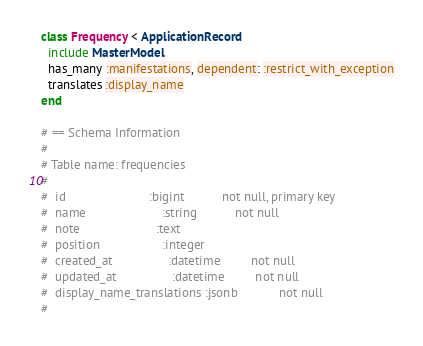Convert code to text. <code><loc_0><loc_0><loc_500><loc_500><_Ruby_>class Frequency < ApplicationRecord
  include MasterModel
  has_many :manifestations, dependent: :restrict_with_exception
  translates :display_name
end

# == Schema Information
#
# Table name: frequencies
#
#  id                        :bigint           not null, primary key
#  name                      :string           not null
#  note                      :text
#  position                  :integer
#  created_at                :datetime         not null
#  updated_at                :datetime         not null
#  display_name_translations :jsonb            not null
#
</code> 